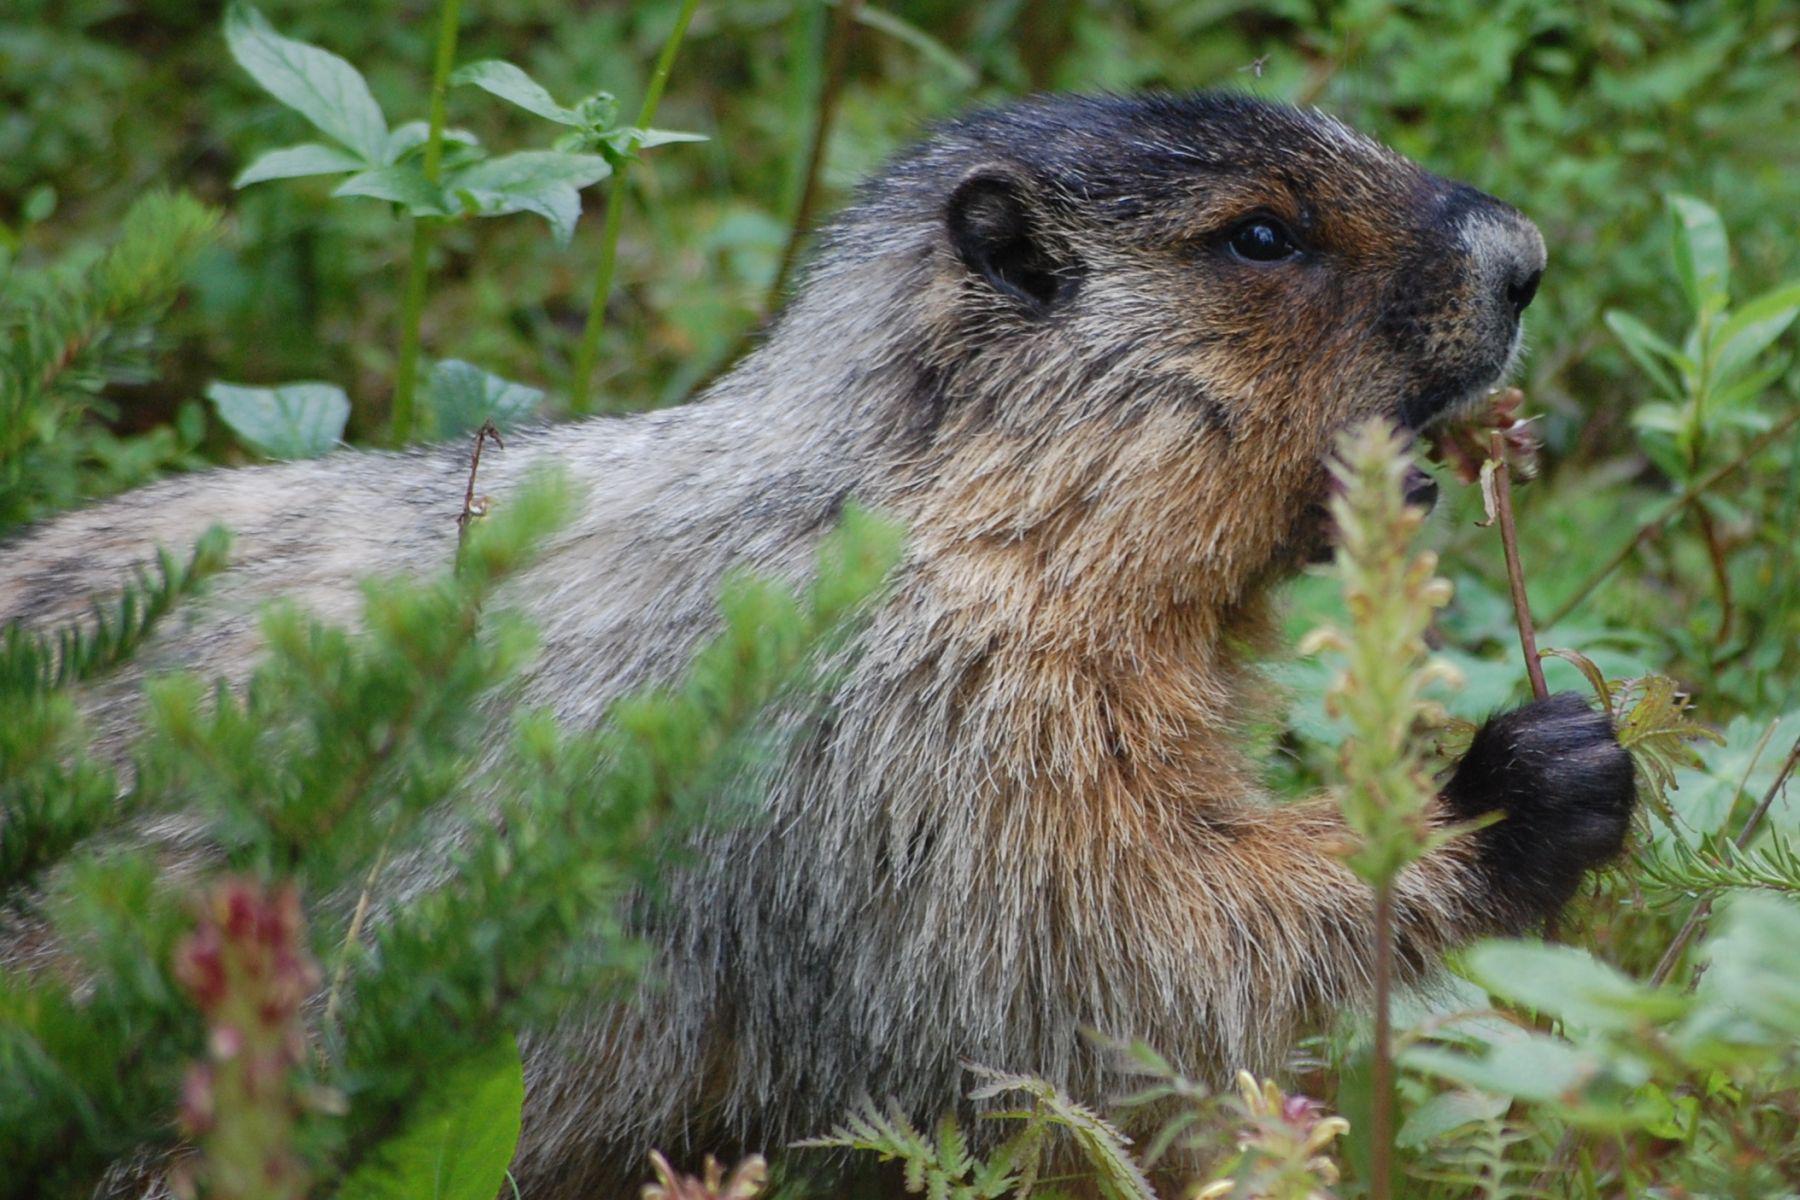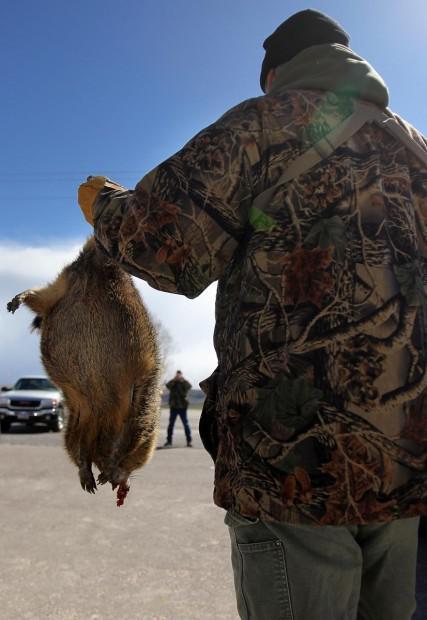The first image is the image on the left, the second image is the image on the right. For the images displayed, is the sentence "At least one of the small mammals is looking directly to the right, alone in it's own image." factually correct? Answer yes or no. Yes. The first image is the image on the left, the second image is the image on the right. Evaluate the accuracy of this statement regarding the images: "The left and right image contains a total of two groundhogs facing the same direction.". Is it true? Answer yes or no. No. 